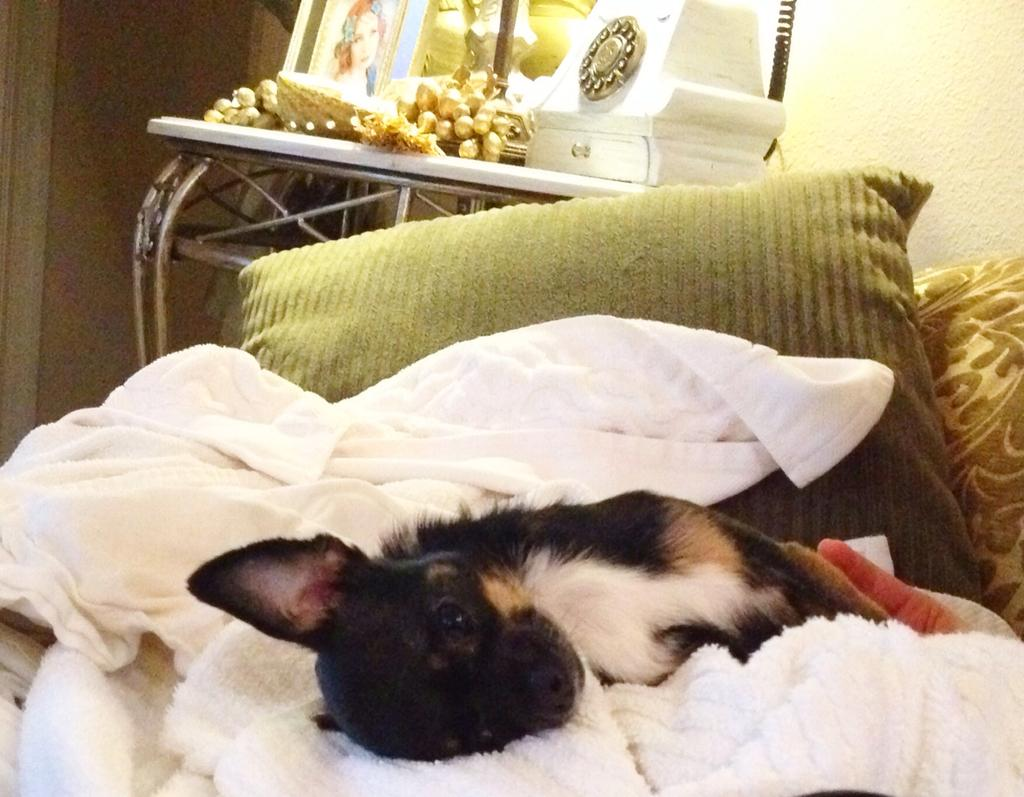What animal is on the bed in the image? There is a dog on the bed in the image. What can be seen in the background of the image? There is a pillow, a frame on a table, and a wall visible in the background of the image. What type of smoke can be seen coming from the dog's ears in the image? There is no smoke present in the image, and the dog's ears are not depicted as emitting any smoke. 